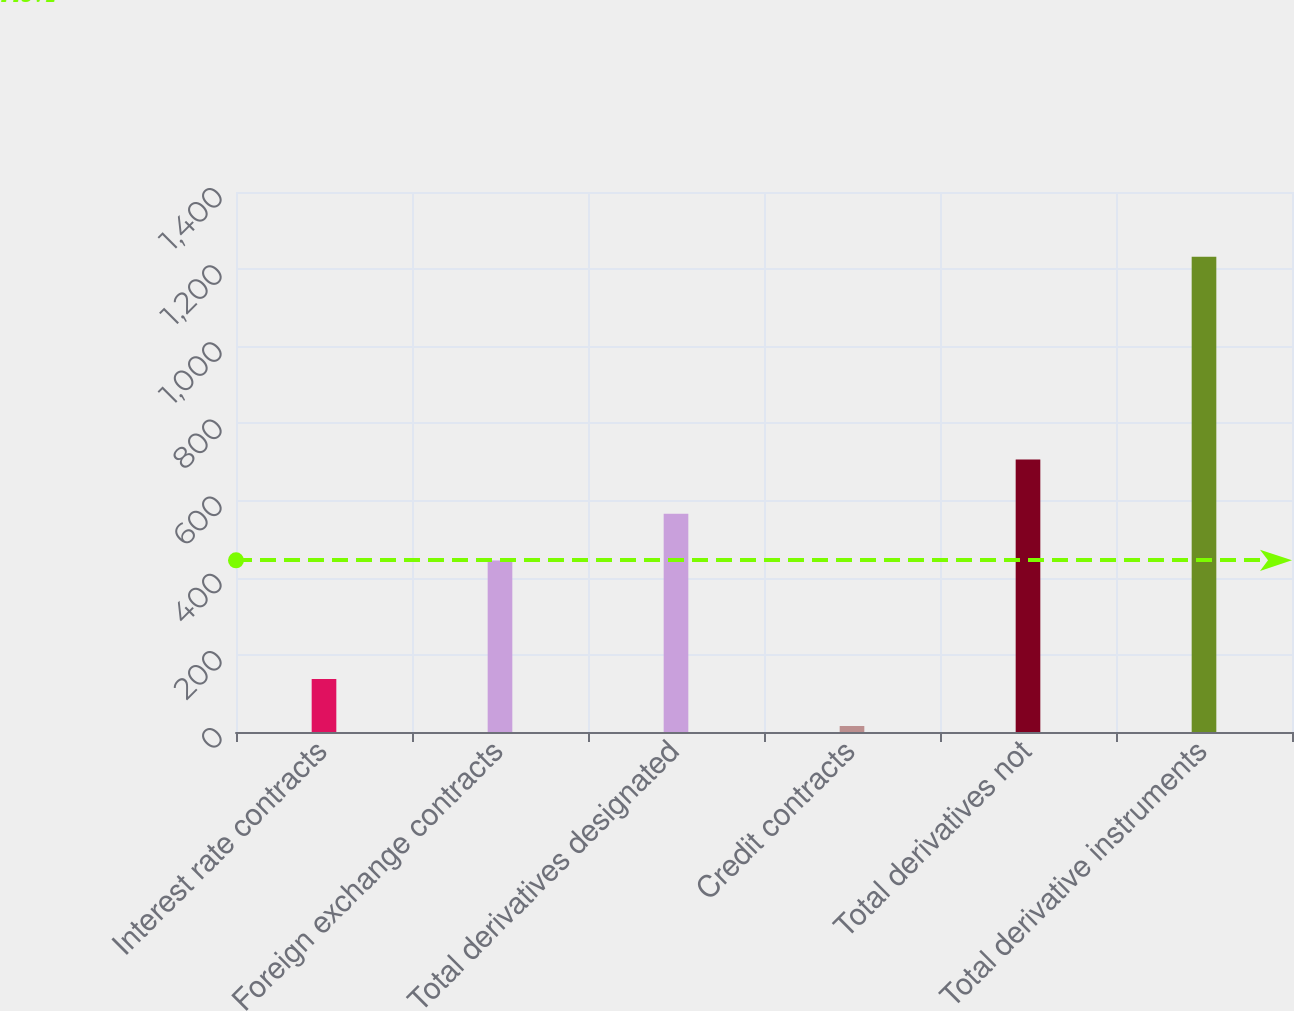<chart> <loc_0><loc_0><loc_500><loc_500><bar_chart><fcel>Interest rate contracts<fcel>Foreign exchange contracts<fcel>Total derivatives designated<fcel>Credit contracts<fcel>Total derivatives not<fcel>Total derivative instruments<nl><fcel>137.17<fcel>444.4<fcel>566.07<fcel>15.5<fcel>706.3<fcel>1232.2<nl></chart> 